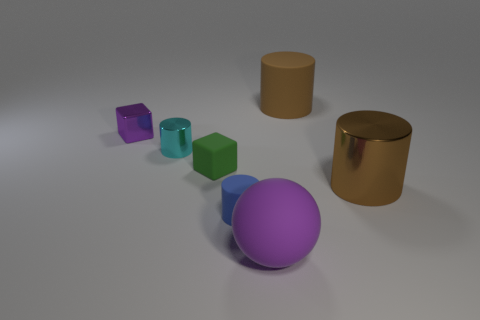Is the number of purple things left of the green rubber thing less than the number of rubber cubes left of the blue matte cylinder?
Keep it short and to the point. No. There is a rubber thing that is behind the large matte sphere and right of the small blue matte thing; how big is it?
Offer a terse response. Large. There is a large object to the right of the large rubber object that is to the right of the big purple matte thing; is there a purple shiny block that is in front of it?
Make the answer very short. No. Are there any purple spheres?
Provide a succinct answer. Yes. Is the number of small purple things that are in front of the tiny cyan metal object greater than the number of big purple rubber balls to the left of the green block?
Make the answer very short. No. There is a blue object that is the same material as the big purple thing; what size is it?
Provide a succinct answer. Small. There is a purple thing that is on the right side of the tiny matte cylinder in front of the large brown metal object that is on the right side of the purple sphere; what is its size?
Provide a short and direct response. Large. There is a big rubber object behind the small blue thing; what is its color?
Give a very brief answer. Brown. Are there more tiny matte blocks in front of the green thing than brown shiny things?
Provide a short and direct response. No. Do the large rubber thing behind the small purple metal thing and the green matte object have the same shape?
Give a very brief answer. No. 